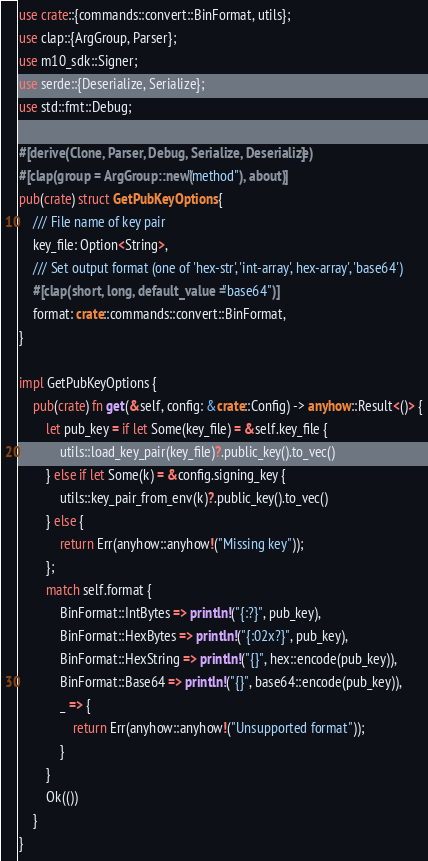Convert code to text. <code><loc_0><loc_0><loc_500><loc_500><_Rust_>use crate::{commands::convert::BinFormat, utils};
use clap::{ArgGroup, Parser};
use m10_sdk::Signer;
use serde::{Deserialize, Serialize};
use std::fmt::Debug;

#[derive(Clone, Parser, Debug, Serialize, Deserialize)]
#[clap(group = ArgGroup::new("method"), about)]
pub(crate) struct GetPubKeyOptions {
    /// File name of key pair
    key_file: Option<String>,
    /// Set output format (one of 'hex-str', 'int-array', hex-array', 'base64')
    #[clap(short, long, default_value = "base64")]
    format: crate::commands::convert::BinFormat,
}

impl GetPubKeyOptions {
    pub(crate) fn get(&self, config: &crate::Config) -> anyhow::Result<()> {
        let pub_key = if let Some(key_file) = &self.key_file {
            utils::load_key_pair(key_file)?.public_key().to_vec()
        } else if let Some(k) = &config.signing_key {
            utils::key_pair_from_env(k)?.public_key().to_vec()
        } else {
            return Err(anyhow::anyhow!("Missing key"));
        };
        match self.format {
            BinFormat::IntBytes => println!("{:?}", pub_key),
            BinFormat::HexBytes => println!("{:02x?}", pub_key),
            BinFormat::HexString => println!("{}", hex::encode(pub_key)),
            BinFormat::Base64 => println!("{}", base64::encode(pub_key)),
            _ => {
                return Err(anyhow::anyhow!("Unsupported format"));
            }
        }
        Ok(())
    }
}
</code> 